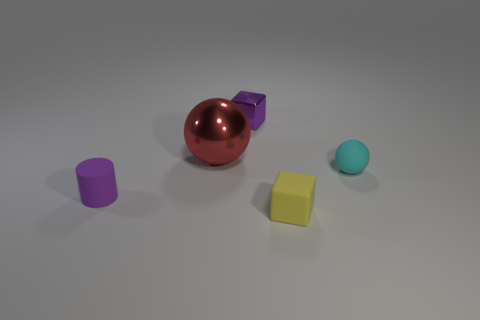Subtract all green blocks. Subtract all red cylinders. How many blocks are left? 2 Subtract all purple spheres. How many gray cylinders are left? 0 Add 5 cyans. How many tiny purples exist? 0 Subtract all small cyan shiny blocks. Subtract all tiny rubber blocks. How many objects are left? 4 Add 4 yellow rubber things. How many yellow rubber things are left? 5 Add 2 yellow rubber things. How many yellow rubber things exist? 3 Add 4 big cyan objects. How many objects exist? 9 Subtract all cyan balls. How many balls are left? 1 Subtract 1 yellow blocks. How many objects are left? 4 Subtract all spheres. How many objects are left? 3 